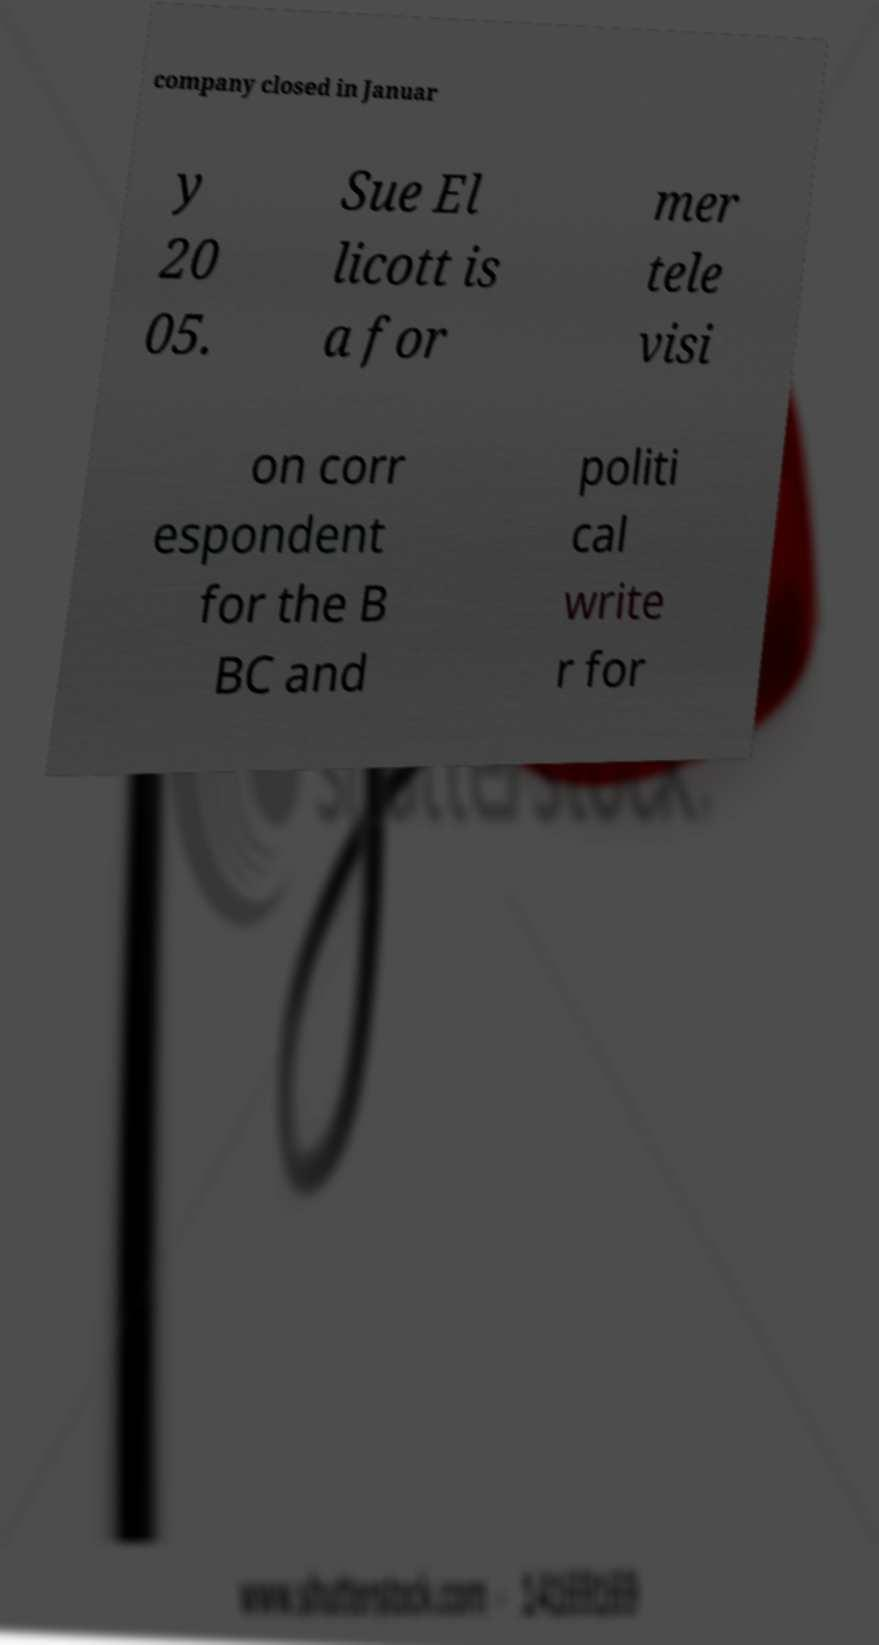Could you assist in decoding the text presented in this image and type it out clearly? company closed in Januar y 20 05. Sue El licott is a for mer tele visi on corr espondent for the B BC and politi cal write r for 